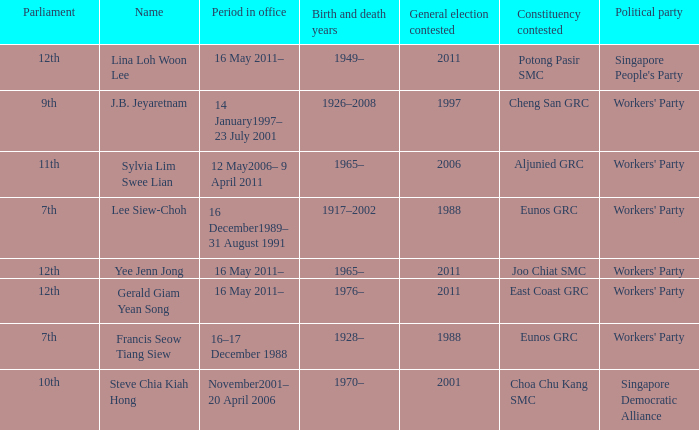What period were conscituency contested is aljunied grc? 12 May2006– 9 April 2011. 